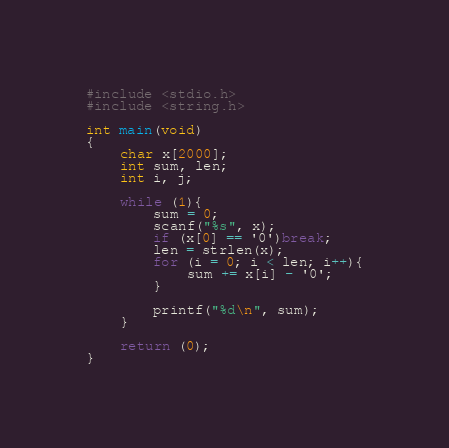Convert code to text. <code><loc_0><loc_0><loc_500><loc_500><_C_>#include <stdio.h>
#include <string.h>

int main(void)
{
	char x[2000];
	int sum, len;
	int i, j;
	
	while (1){
		sum = 0;
		scanf("%s", x);
		if (x[0] == '0')break;
		len = strlen(x);
		for (i = 0; i < len; i++){
			sum += x[i] - '0';
		}
		
		printf("%d\n", sum);
	}
	
	return (0);
}</code> 